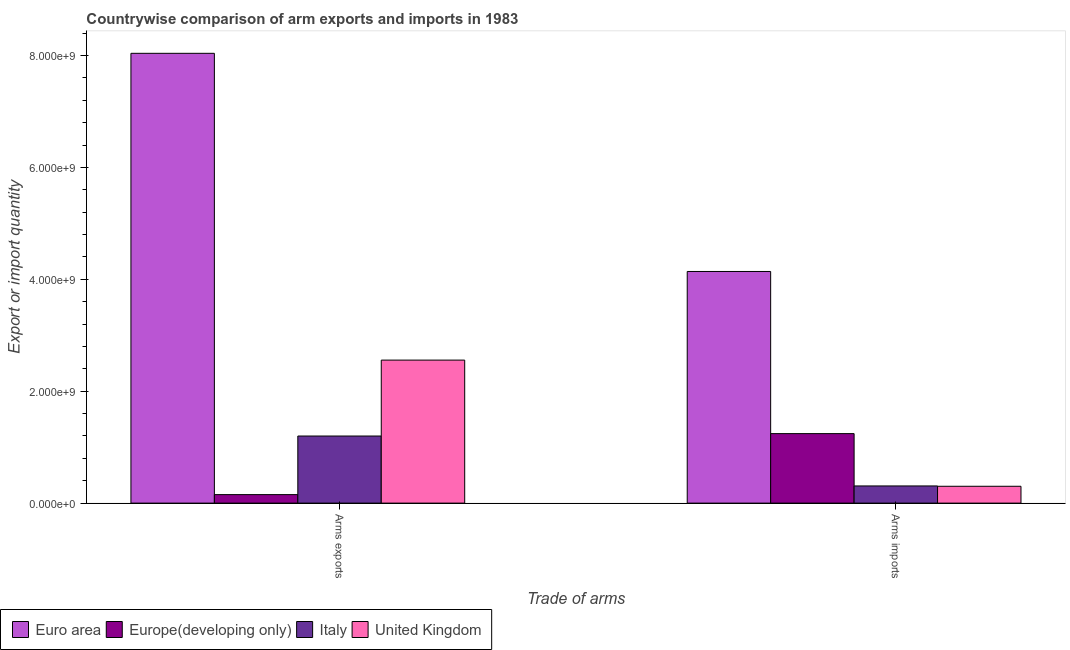How many different coloured bars are there?
Offer a very short reply. 4. Are the number of bars per tick equal to the number of legend labels?
Your response must be concise. Yes. Are the number of bars on each tick of the X-axis equal?
Make the answer very short. Yes. What is the label of the 2nd group of bars from the left?
Your answer should be compact. Arms imports. What is the arms exports in United Kingdom?
Your answer should be compact. 2.56e+09. Across all countries, what is the maximum arms exports?
Your answer should be compact. 8.04e+09. Across all countries, what is the minimum arms imports?
Your answer should be very brief. 3.01e+08. In which country was the arms imports maximum?
Ensure brevity in your answer.  Euro area. In which country was the arms exports minimum?
Provide a short and direct response. Europe(developing only). What is the total arms exports in the graph?
Provide a short and direct response. 1.19e+1. What is the difference between the arms exports in United Kingdom and that in Europe(developing only)?
Offer a very short reply. 2.40e+09. What is the difference between the arms imports in Europe(developing only) and the arms exports in Euro area?
Provide a succinct answer. -6.80e+09. What is the average arms imports per country?
Provide a succinct answer. 1.50e+09. What is the difference between the arms exports and arms imports in Euro area?
Your answer should be compact. 3.90e+09. What is the ratio of the arms exports in United Kingdom to that in Italy?
Ensure brevity in your answer.  2.13. What does the 1st bar from the right in Arms imports represents?
Ensure brevity in your answer.  United Kingdom. Are the values on the major ticks of Y-axis written in scientific E-notation?
Offer a very short reply. Yes. How many legend labels are there?
Ensure brevity in your answer.  4. How are the legend labels stacked?
Provide a succinct answer. Horizontal. What is the title of the graph?
Ensure brevity in your answer.  Countrywise comparison of arm exports and imports in 1983. What is the label or title of the X-axis?
Your answer should be compact. Trade of arms. What is the label or title of the Y-axis?
Make the answer very short. Export or import quantity. What is the Export or import quantity in Euro area in Arms exports?
Provide a short and direct response. 8.04e+09. What is the Export or import quantity of Europe(developing only) in Arms exports?
Your answer should be very brief. 1.52e+08. What is the Export or import quantity of Italy in Arms exports?
Ensure brevity in your answer.  1.20e+09. What is the Export or import quantity of United Kingdom in Arms exports?
Ensure brevity in your answer.  2.56e+09. What is the Export or import quantity in Euro area in Arms imports?
Provide a succinct answer. 4.14e+09. What is the Export or import quantity in Europe(developing only) in Arms imports?
Give a very brief answer. 1.24e+09. What is the Export or import quantity in Italy in Arms imports?
Keep it short and to the point. 3.07e+08. What is the Export or import quantity in United Kingdom in Arms imports?
Keep it short and to the point. 3.01e+08. Across all Trade of arms, what is the maximum Export or import quantity in Euro area?
Give a very brief answer. 8.04e+09. Across all Trade of arms, what is the maximum Export or import quantity in Europe(developing only)?
Your response must be concise. 1.24e+09. Across all Trade of arms, what is the maximum Export or import quantity of Italy?
Your answer should be very brief. 1.20e+09. Across all Trade of arms, what is the maximum Export or import quantity in United Kingdom?
Your answer should be compact. 2.56e+09. Across all Trade of arms, what is the minimum Export or import quantity of Euro area?
Your answer should be very brief. 4.14e+09. Across all Trade of arms, what is the minimum Export or import quantity of Europe(developing only)?
Provide a short and direct response. 1.52e+08. Across all Trade of arms, what is the minimum Export or import quantity in Italy?
Ensure brevity in your answer.  3.07e+08. Across all Trade of arms, what is the minimum Export or import quantity in United Kingdom?
Make the answer very short. 3.01e+08. What is the total Export or import quantity of Euro area in the graph?
Offer a terse response. 1.22e+1. What is the total Export or import quantity of Europe(developing only) in the graph?
Ensure brevity in your answer.  1.39e+09. What is the total Export or import quantity of Italy in the graph?
Offer a very short reply. 1.51e+09. What is the total Export or import quantity of United Kingdom in the graph?
Your response must be concise. 2.86e+09. What is the difference between the Export or import quantity of Euro area in Arms exports and that in Arms imports?
Your answer should be compact. 3.90e+09. What is the difference between the Export or import quantity of Europe(developing only) in Arms exports and that in Arms imports?
Your response must be concise. -1.09e+09. What is the difference between the Export or import quantity in Italy in Arms exports and that in Arms imports?
Your response must be concise. 8.92e+08. What is the difference between the Export or import quantity in United Kingdom in Arms exports and that in Arms imports?
Your response must be concise. 2.26e+09. What is the difference between the Export or import quantity of Euro area in Arms exports and the Export or import quantity of Europe(developing only) in Arms imports?
Your answer should be very brief. 6.80e+09. What is the difference between the Export or import quantity of Euro area in Arms exports and the Export or import quantity of Italy in Arms imports?
Make the answer very short. 7.73e+09. What is the difference between the Export or import quantity in Euro area in Arms exports and the Export or import quantity in United Kingdom in Arms imports?
Ensure brevity in your answer.  7.74e+09. What is the difference between the Export or import quantity of Europe(developing only) in Arms exports and the Export or import quantity of Italy in Arms imports?
Make the answer very short. -1.55e+08. What is the difference between the Export or import quantity of Europe(developing only) in Arms exports and the Export or import quantity of United Kingdom in Arms imports?
Your answer should be very brief. -1.49e+08. What is the difference between the Export or import quantity of Italy in Arms exports and the Export or import quantity of United Kingdom in Arms imports?
Offer a very short reply. 8.98e+08. What is the average Export or import quantity in Euro area per Trade of arms?
Offer a very short reply. 6.09e+09. What is the average Export or import quantity of Europe(developing only) per Trade of arms?
Ensure brevity in your answer.  6.97e+08. What is the average Export or import quantity of Italy per Trade of arms?
Offer a terse response. 7.53e+08. What is the average Export or import quantity in United Kingdom per Trade of arms?
Make the answer very short. 1.43e+09. What is the difference between the Export or import quantity in Euro area and Export or import quantity in Europe(developing only) in Arms exports?
Provide a short and direct response. 7.89e+09. What is the difference between the Export or import quantity in Euro area and Export or import quantity in Italy in Arms exports?
Make the answer very short. 6.84e+09. What is the difference between the Export or import quantity of Euro area and Export or import quantity of United Kingdom in Arms exports?
Offer a very short reply. 5.48e+09. What is the difference between the Export or import quantity in Europe(developing only) and Export or import quantity in Italy in Arms exports?
Your answer should be compact. -1.05e+09. What is the difference between the Export or import quantity in Europe(developing only) and Export or import quantity in United Kingdom in Arms exports?
Your response must be concise. -2.40e+09. What is the difference between the Export or import quantity of Italy and Export or import quantity of United Kingdom in Arms exports?
Give a very brief answer. -1.36e+09. What is the difference between the Export or import quantity in Euro area and Export or import quantity in Europe(developing only) in Arms imports?
Provide a short and direct response. 2.90e+09. What is the difference between the Export or import quantity in Euro area and Export or import quantity in Italy in Arms imports?
Your answer should be very brief. 3.83e+09. What is the difference between the Export or import quantity in Euro area and Export or import quantity in United Kingdom in Arms imports?
Your response must be concise. 3.84e+09. What is the difference between the Export or import quantity in Europe(developing only) and Export or import quantity in Italy in Arms imports?
Your answer should be very brief. 9.35e+08. What is the difference between the Export or import quantity of Europe(developing only) and Export or import quantity of United Kingdom in Arms imports?
Give a very brief answer. 9.41e+08. What is the ratio of the Export or import quantity in Euro area in Arms exports to that in Arms imports?
Your answer should be very brief. 1.94. What is the ratio of the Export or import quantity in Europe(developing only) in Arms exports to that in Arms imports?
Your answer should be very brief. 0.12. What is the ratio of the Export or import quantity of Italy in Arms exports to that in Arms imports?
Offer a terse response. 3.91. What is the ratio of the Export or import quantity in United Kingdom in Arms exports to that in Arms imports?
Offer a terse response. 8.49. What is the difference between the highest and the second highest Export or import quantity in Euro area?
Provide a short and direct response. 3.90e+09. What is the difference between the highest and the second highest Export or import quantity of Europe(developing only)?
Your answer should be compact. 1.09e+09. What is the difference between the highest and the second highest Export or import quantity of Italy?
Keep it short and to the point. 8.92e+08. What is the difference between the highest and the second highest Export or import quantity in United Kingdom?
Provide a short and direct response. 2.26e+09. What is the difference between the highest and the lowest Export or import quantity in Euro area?
Your answer should be very brief. 3.90e+09. What is the difference between the highest and the lowest Export or import quantity of Europe(developing only)?
Offer a very short reply. 1.09e+09. What is the difference between the highest and the lowest Export or import quantity of Italy?
Make the answer very short. 8.92e+08. What is the difference between the highest and the lowest Export or import quantity in United Kingdom?
Your answer should be very brief. 2.26e+09. 